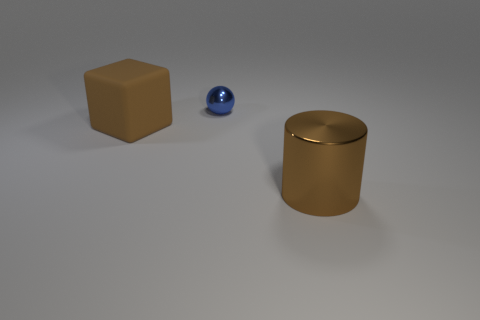Add 2 brown matte blocks. How many objects exist? 5 Subtract all cylinders. How many objects are left? 2 Subtract 0 yellow blocks. How many objects are left? 3 Subtract all small spheres. Subtract all large things. How many objects are left? 0 Add 2 small balls. How many small balls are left? 3 Add 3 tiny balls. How many tiny balls exist? 4 